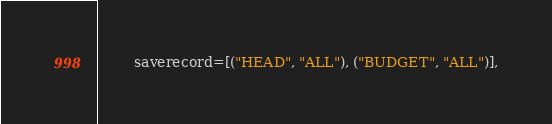<code> <loc_0><loc_0><loc_500><loc_500><_Python_>        saverecord=[("HEAD", "ALL"), ("BUDGET", "ALL")],</code> 